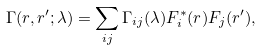Convert formula to latex. <formula><loc_0><loc_0><loc_500><loc_500>\Gamma ( r , r ^ { \prime } ; \lambda ) = \sum _ { i j } \Gamma _ { i j } ( \lambda ) F ^ { * } _ { i } ( r ) F _ { j } ( r ^ { \prime } ) ,</formula> 